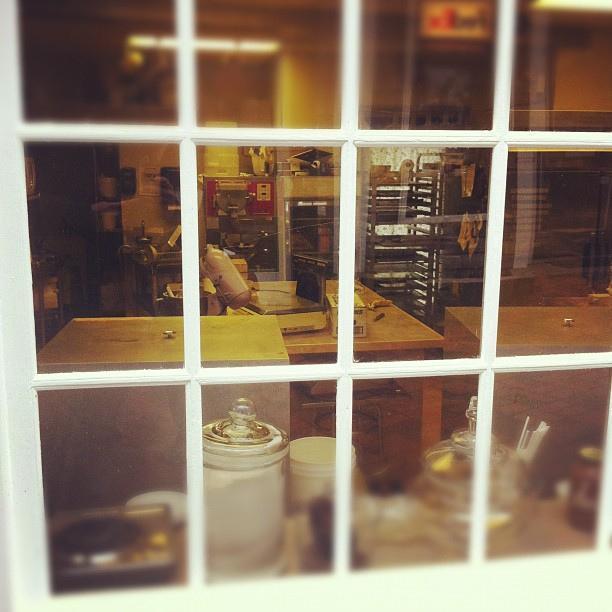How many dining tables can be seen?
Give a very brief answer. 2. How many motorcycles can be seen in the picture?
Give a very brief answer. 0. 